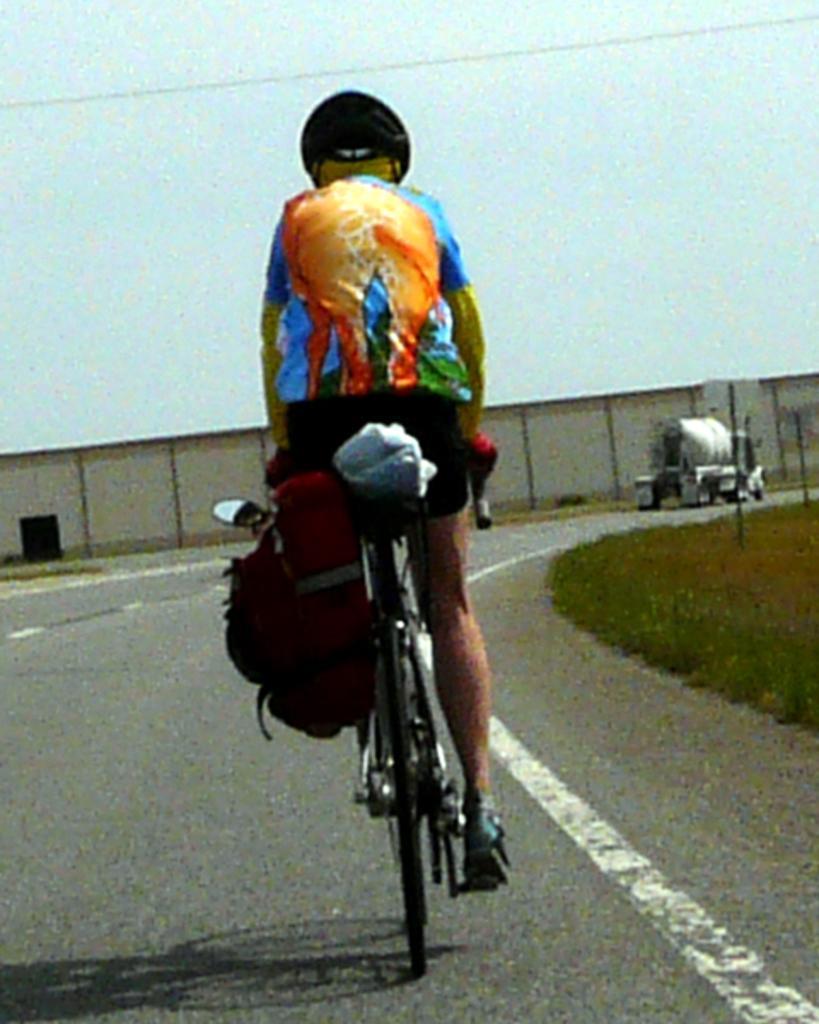How would you summarize this image in a sentence or two? In this image in the center there is one person sitting on a cycle and on the cycle there are some bags, and in the background there is a vehicle, wall and at the bottom there is road. And on the right side there is grass, at the top there is sky and wires. 